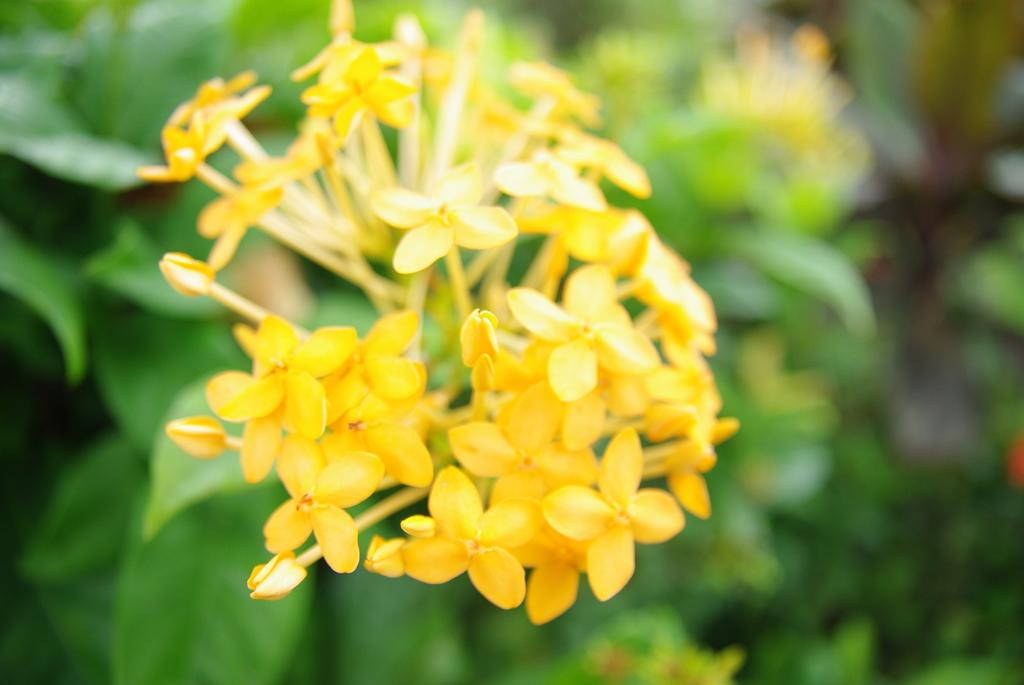What type of flowers are in the center of the image? There are yellow color flowers in the center of the image. What can be seen in the background of the image? There are plants in the background of the image. Are there any other objects visible in the background? Yes, there are other objects visible in the background of the image. What type of lettuce is being eaten by the monkey in the image? There is no lettuce or monkey present in the image. 